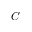Convert formula to latex. <formula><loc_0><loc_0><loc_500><loc_500>C</formula> 